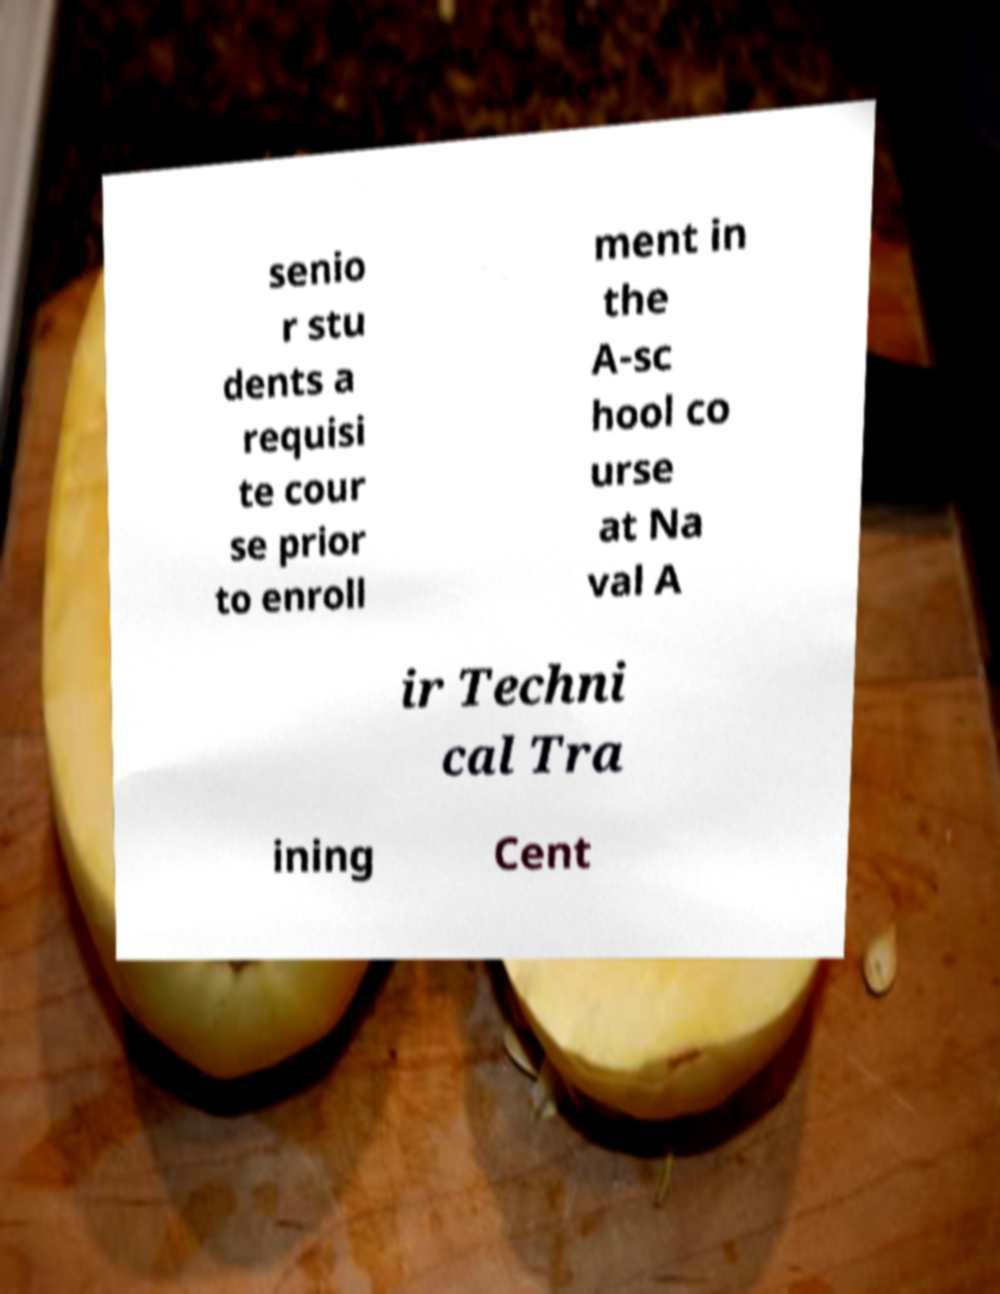Could you extract and type out the text from this image? senio r stu dents a requisi te cour se prior to enroll ment in the A-sc hool co urse at Na val A ir Techni cal Tra ining Cent 